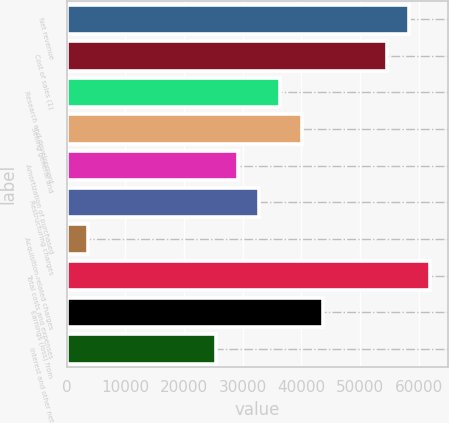<chart> <loc_0><loc_0><loc_500><loc_500><bar_chart><fcel>Net revenue<fcel>Cost of sales (1)<fcel>Research and development<fcel>Selling general and<fcel>Amortization of purchased<fcel>Restructuring charges<fcel>Acquisition-related charges<fcel>Total costs and expenses<fcel>Earnings (loss) from<fcel>Interest and other net<nl><fcel>58315.2<fcel>54670.5<fcel>36447<fcel>40091.7<fcel>29157.7<fcel>32802.3<fcel>3644.82<fcel>61959.9<fcel>43736.4<fcel>25513<nl></chart> 